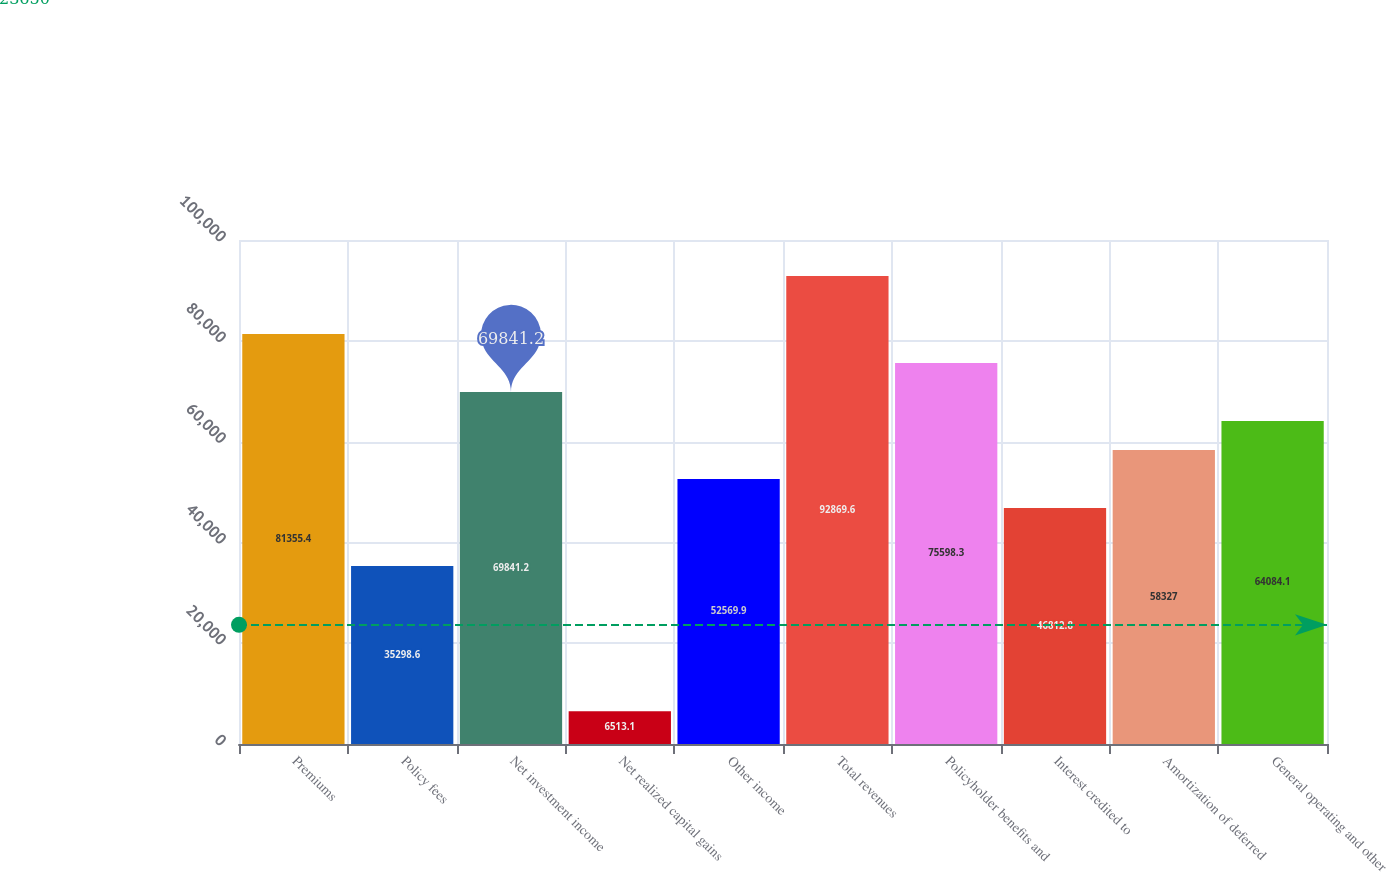<chart> <loc_0><loc_0><loc_500><loc_500><bar_chart><fcel>Premiums<fcel>Policy fees<fcel>Net investment income<fcel>Net realized capital gains<fcel>Other income<fcel>Total revenues<fcel>Policyholder benefits and<fcel>Interest credited to<fcel>Amortization of deferred<fcel>General operating and other<nl><fcel>81355.4<fcel>35298.6<fcel>69841.2<fcel>6513.1<fcel>52569.9<fcel>92869.6<fcel>75598.3<fcel>46812.8<fcel>58327<fcel>64084.1<nl></chart> 